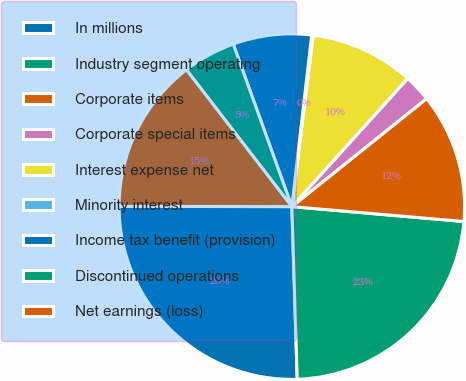Convert chart. <chart><loc_0><loc_0><loc_500><loc_500><pie_chart><fcel>In millions<fcel>Industry segment operating<fcel>Corporate items<fcel>Corporate special items<fcel>Interest expense net<fcel>Minority interest<fcel>Income tax benefit (provision)<fcel>Discontinued operations<fcel>Net earnings (loss)<nl><fcel>25.52%<fcel>23.13%<fcel>12.13%<fcel>2.54%<fcel>9.73%<fcel>0.14%<fcel>7.34%<fcel>4.94%<fcel>14.53%<nl></chart> 